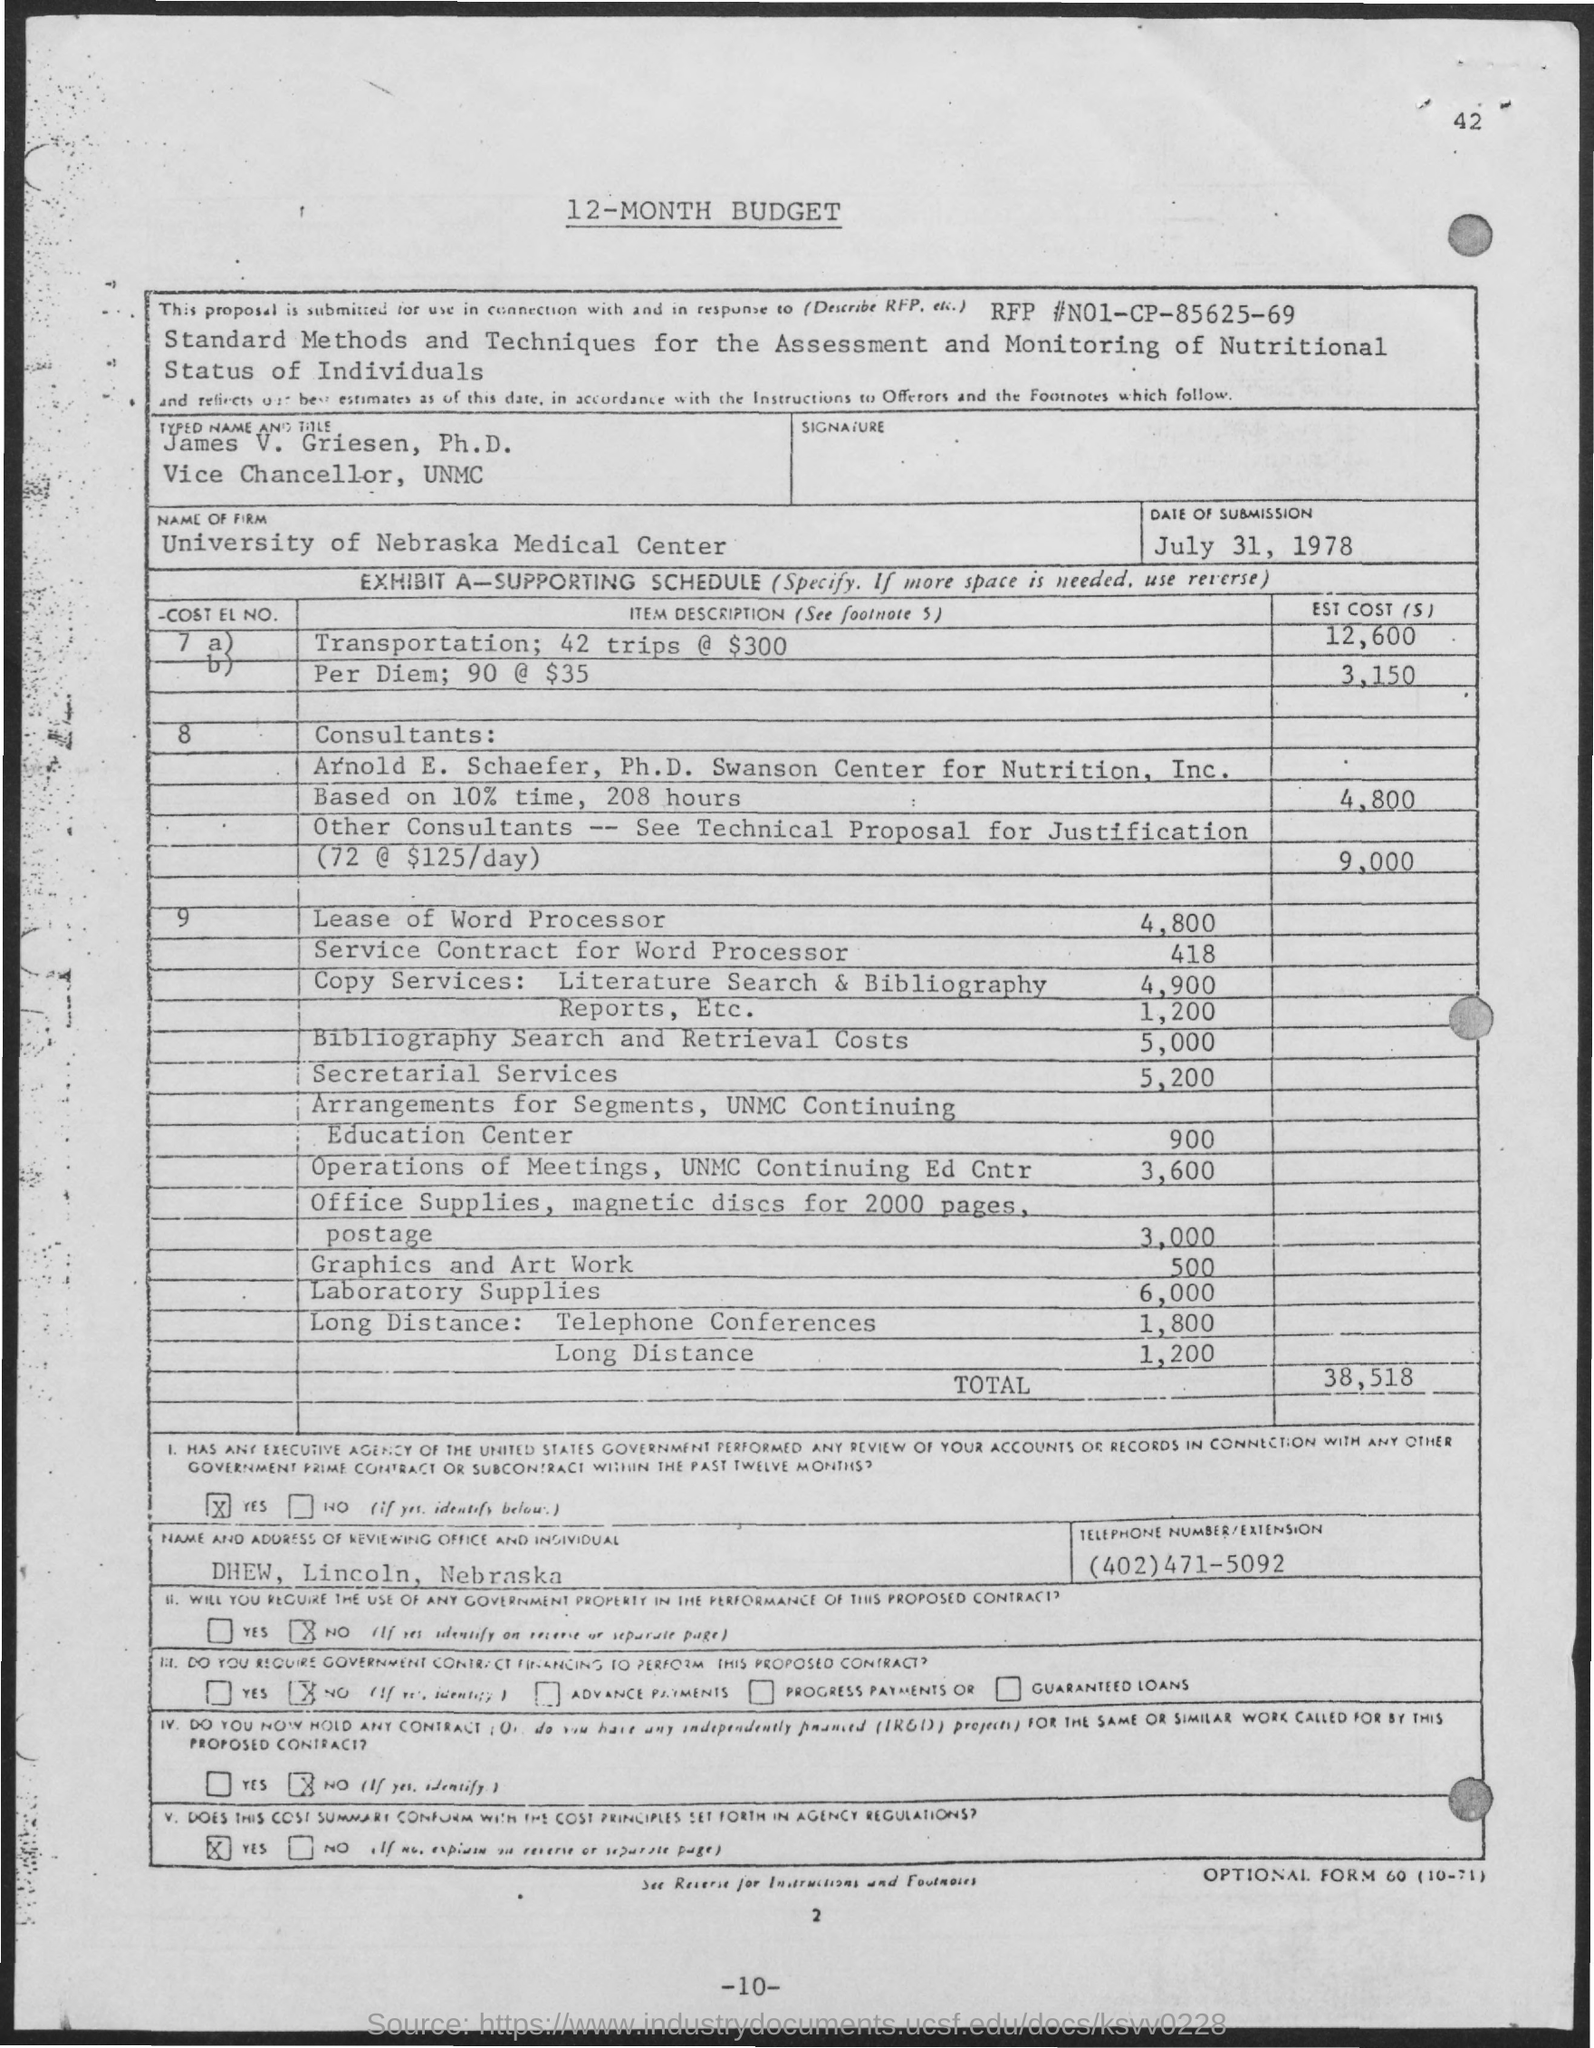Who is the Vice Chancellor of UNMC?
Make the answer very short. James V. Griesen. What is the name of the firm?
Your answer should be very brief. University of Nebraska Medical Center. 